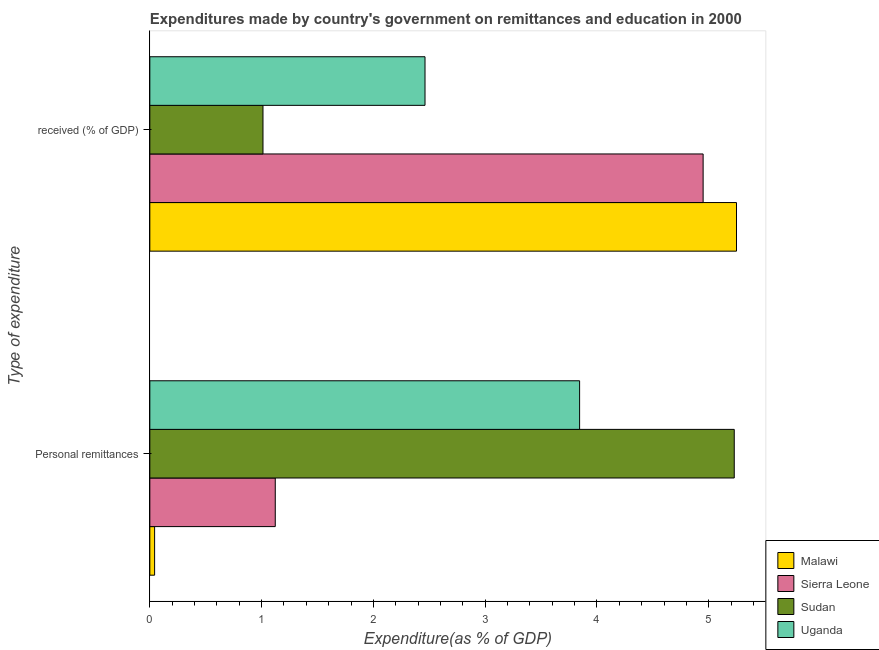How many different coloured bars are there?
Offer a terse response. 4. Are the number of bars on each tick of the Y-axis equal?
Your response must be concise. Yes. How many bars are there on the 2nd tick from the top?
Make the answer very short. 4. What is the label of the 1st group of bars from the top?
Provide a succinct answer.  received (% of GDP). What is the expenditure in personal remittances in Sudan?
Offer a terse response. 5.23. Across all countries, what is the maximum expenditure in education?
Your answer should be compact. 5.25. Across all countries, what is the minimum expenditure in education?
Make the answer very short. 1.01. In which country was the expenditure in education maximum?
Your answer should be compact. Malawi. In which country was the expenditure in education minimum?
Keep it short and to the point. Sudan. What is the total expenditure in education in the graph?
Make the answer very short. 13.67. What is the difference between the expenditure in personal remittances in Malawi and that in Sierra Leone?
Offer a very short reply. -1.08. What is the difference between the expenditure in education in Sudan and the expenditure in personal remittances in Uganda?
Your answer should be very brief. -2.83. What is the average expenditure in education per country?
Ensure brevity in your answer.  3.42. What is the difference between the expenditure in personal remittances and expenditure in education in Sudan?
Your response must be concise. 4.22. What is the ratio of the expenditure in personal remittances in Malawi to that in Sierra Leone?
Give a very brief answer. 0.04. In how many countries, is the expenditure in education greater than the average expenditure in education taken over all countries?
Give a very brief answer. 2. What does the 4th bar from the top in  received (% of GDP) represents?
Ensure brevity in your answer.  Malawi. What does the 4th bar from the bottom in Personal remittances represents?
Offer a terse response. Uganda. Are all the bars in the graph horizontal?
Ensure brevity in your answer.  Yes. How many countries are there in the graph?
Your answer should be compact. 4. Are the values on the major ticks of X-axis written in scientific E-notation?
Provide a short and direct response. No. Does the graph contain grids?
Offer a terse response. No. Where does the legend appear in the graph?
Provide a short and direct response. Bottom right. How many legend labels are there?
Offer a terse response. 4. How are the legend labels stacked?
Your answer should be very brief. Vertical. What is the title of the graph?
Give a very brief answer. Expenditures made by country's government on remittances and education in 2000. What is the label or title of the X-axis?
Offer a terse response. Expenditure(as % of GDP). What is the label or title of the Y-axis?
Ensure brevity in your answer.  Type of expenditure. What is the Expenditure(as % of GDP) of Malawi in Personal remittances?
Offer a very short reply. 0.04. What is the Expenditure(as % of GDP) of Sierra Leone in Personal remittances?
Ensure brevity in your answer.  1.12. What is the Expenditure(as % of GDP) of Sudan in Personal remittances?
Provide a succinct answer. 5.23. What is the Expenditure(as % of GDP) in Uganda in Personal remittances?
Ensure brevity in your answer.  3.84. What is the Expenditure(as % of GDP) of Malawi in  received (% of GDP)?
Your answer should be very brief. 5.25. What is the Expenditure(as % of GDP) in Sierra Leone in  received (% of GDP)?
Give a very brief answer. 4.95. What is the Expenditure(as % of GDP) of Sudan in  received (% of GDP)?
Provide a succinct answer. 1.01. What is the Expenditure(as % of GDP) in Uganda in  received (% of GDP)?
Provide a succinct answer. 2.46. Across all Type of expenditure, what is the maximum Expenditure(as % of GDP) in Malawi?
Your response must be concise. 5.25. Across all Type of expenditure, what is the maximum Expenditure(as % of GDP) in Sierra Leone?
Your answer should be very brief. 4.95. Across all Type of expenditure, what is the maximum Expenditure(as % of GDP) of Sudan?
Make the answer very short. 5.23. Across all Type of expenditure, what is the maximum Expenditure(as % of GDP) in Uganda?
Keep it short and to the point. 3.84. Across all Type of expenditure, what is the minimum Expenditure(as % of GDP) in Malawi?
Make the answer very short. 0.04. Across all Type of expenditure, what is the minimum Expenditure(as % of GDP) of Sierra Leone?
Keep it short and to the point. 1.12. Across all Type of expenditure, what is the minimum Expenditure(as % of GDP) in Sudan?
Make the answer very short. 1.01. Across all Type of expenditure, what is the minimum Expenditure(as % of GDP) of Uganda?
Keep it short and to the point. 2.46. What is the total Expenditure(as % of GDP) in Malawi in the graph?
Your response must be concise. 5.29. What is the total Expenditure(as % of GDP) in Sierra Leone in the graph?
Provide a short and direct response. 6.07. What is the total Expenditure(as % of GDP) of Sudan in the graph?
Your answer should be compact. 6.24. What is the total Expenditure(as % of GDP) in Uganda in the graph?
Offer a very short reply. 6.31. What is the difference between the Expenditure(as % of GDP) of Malawi in Personal remittances and that in  received (% of GDP)?
Give a very brief answer. -5.21. What is the difference between the Expenditure(as % of GDP) of Sierra Leone in Personal remittances and that in  received (% of GDP)?
Your answer should be very brief. -3.83. What is the difference between the Expenditure(as % of GDP) of Sudan in Personal remittances and that in  received (% of GDP)?
Provide a short and direct response. 4.22. What is the difference between the Expenditure(as % of GDP) in Uganda in Personal remittances and that in  received (% of GDP)?
Your answer should be compact. 1.38. What is the difference between the Expenditure(as % of GDP) in Malawi in Personal remittances and the Expenditure(as % of GDP) in Sierra Leone in  received (% of GDP)?
Your response must be concise. -4.91. What is the difference between the Expenditure(as % of GDP) of Malawi in Personal remittances and the Expenditure(as % of GDP) of Sudan in  received (% of GDP)?
Offer a terse response. -0.97. What is the difference between the Expenditure(as % of GDP) in Malawi in Personal remittances and the Expenditure(as % of GDP) in Uganda in  received (% of GDP)?
Your response must be concise. -2.42. What is the difference between the Expenditure(as % of GDP) in Sierra Leone in Personal remittances and the Expenditure(as % of GDP) in Sudan in  received (% of GDP)?
Ensure brevity in your answer.  0.11. What is the difference between the Expenditure(as % of GDP) of Sierra Leone in Personal remittances and the Expenditure(as % of GDP) of Uganda in  received (% of GDP)?
Your answer should be very brief. -1.34. What is the difference between the Expenditure(as % of GDP) of Sudan in Personal remittances and the Expenditure(as % of GDP) of Uganda in  received (% of GDP)?
Your response must be concise. 2.77. What is the average Expenditure(as % of GDP) of Malawi per Type of expenditure?
Provide a succinct answer. 2.65. What is the average Expenditure(as % of GDP) of Sierra Leone per Type of expenditure?
Your answer should be very brief. 3.04. What is the average Expenditure(as % of GDP) in Sudan per Type of expenditure?
Ensure brevity in your answer.  3.12. What is the average Expenditure(as % of GDP) in Uganda per Type of expenditure?
Offer a terse response. 3.15. What is the difference between the Expenditure(as % of GDP) of Malawi and Expenditure(as % of GDP) of Sierra Leone in Personal remittances?
Provide a succinct answer. -1.08. What is the difference between the Expenditure(as % of GDP) of Malawi and Expenditure(as % of GDP) of Sudan in Personal remittances?
Your answer should be compact. -5.18. What is the difference between the Expenditure(as % of GDP) in Malawi and Expenditure(as % of GDP) in Uganda in Personal remittances?
Provide a succinct answer. -3.8. What is the difference between the Expenditure(as % of GDP) of Sierra Leone and Expenditure(as % of GDP) of Sudan in Personal remittances?
Offer a very short reply. -4.11. What is the difference between the Expenditure(as % of GDP) of Sierra Leone and Expenditure(as % of GDP) of Uganda in Personal remittances?
Provide a succinct answer. -2.72. What is the difference between the Expenditure(as % of GDP) of Sudan and Expenditure(as % of GDP) of Uganda in Personal remittances?
Your answer should be very brief. 1.38. What is the difference between the Expenditure(as % of GDP) of Malawi and Expenditure(as % of GDP) of Sierra Leone in  received (% of GDP)?
Offer a terse response. 0.3. What is the difference between the Expenditure(as % of GDP) of Malawi and Expenditure(as % of GDP) of Sudan in  received (% of GDP)?
Offer a terse response. 4.24. What is the difference between the Expenditure(as % of GDP) in Malawi and Expenditure(as % of GDP) in Uganda in  received (% of GDP)?
Offer a terse response. 2.79. What is the difference between the Expenditure(as % of GDP) of Sierra Leone and Expenditure(as % of GDP) of Sudan in  received (% of GDP)?
Offer a terse response. 3.94. What is the difference between the Expenditure(as % of GDP) in Sierra Leone and Expenditure(as % of GDP) in Uganda in  received (% of GDP)?
Provide a short and direct response. 2.49. What is the difference between the Expenditure(as % of GDP) of Sudan and Expenditure(as % of GDP) of Uganda in  received (% of GDP)?
Your answer should be compact. -1.45. What is the ratio of the Expenditure(as % of GDP) in Malawi in Personal remittances to that in  received (% of GDP)?
Give a very brief answer. 0.01. What is the ratio of the Expenditure(as % of GDP) in Sierra Leone in Personal remittances to that in  received (% of GDP)?
Make the answer very short. 0.23. What is the ratio of the Expenditure(as % of GDP) in Sudan in Personal remittances to that in  received (% of GDP)?
Offer a very short reply. 5.16. What is the ratio of the Expenditure(as % of GDP) of Uganda in Personal remittances to that in  received (% of GDP)?
Ensure brevity in your answer.  1.56. What is the difference between the highest and the second highest Expenditure(as % of GDP) in Malawi?
Your answer should be very brief. 5.21. What is the difference between the highest and the second highest Expenditure(as % of GDP) in Sierra Leone?
Make the answer very short. 3.83. What is the difference between the highest and the second highest Expenditure(as % of GDP) of Sudan?
Give a very brief answer. 4.22. What is the difference between the highest and the second highest Expenditure(as % of GDP) of Uganda?
Your response must be concise. 1.38. What is the difference between the highest and the lowest Expenditure(as % of GDP) in Malawi?
Your answer should be very brief. 5.21. What is the difference between the highest and the lowest Expenditure(as % of GDP) in Sierra Leone?
Your answer should be very brief. 3.83. What is the difference between the highest and the lowest Expenditure(as % of GDP) of Sudan?
Your response must be concise. 4.22. What is the difference between the highest and the lowest Expenditure(as % of GDP) of Uganda?
Your response must be concise. 1.38. 